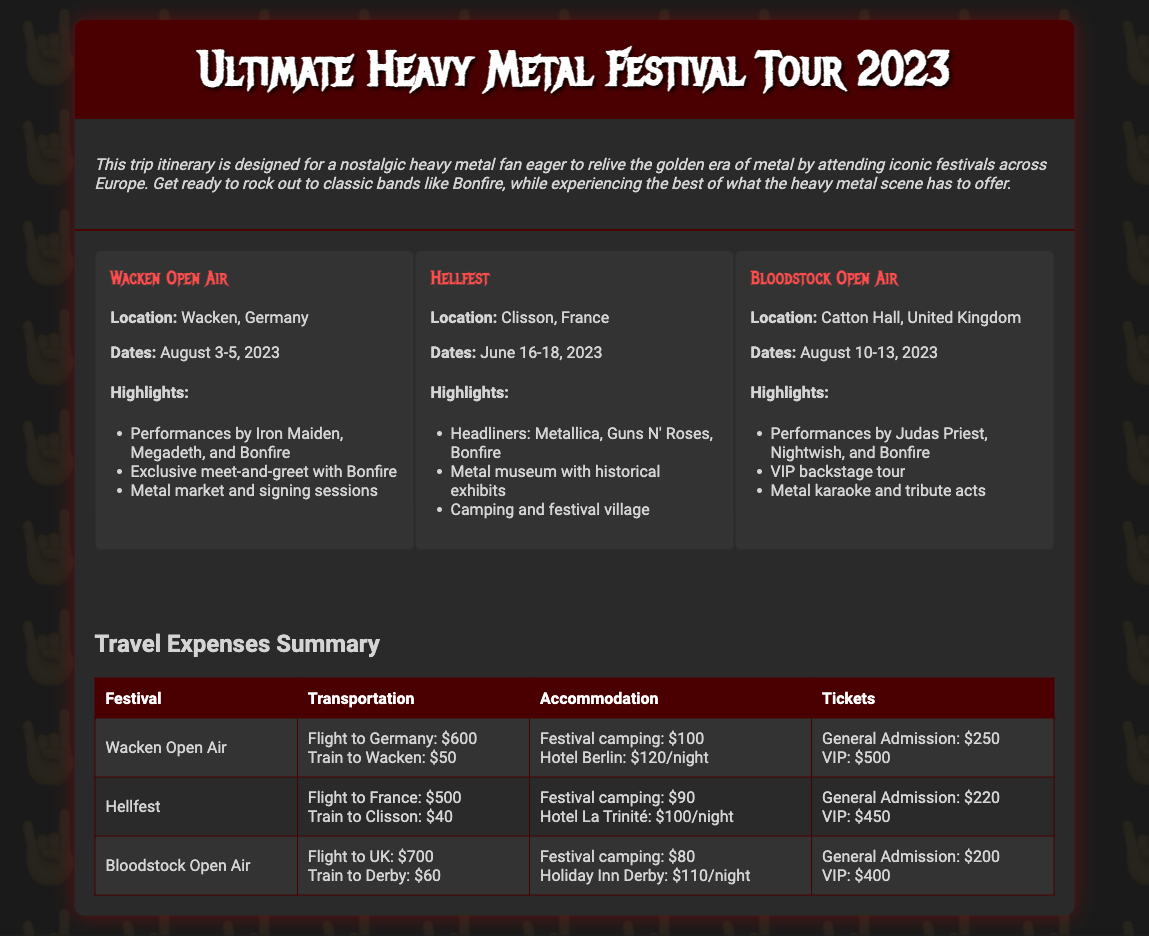What are the dates for Wacken Open Air? The document specifies the dates for Wacken Open Air as August 3-5, 2023.
Answer: August 3-5, 2023 What is the location of Hellfest? The document states that Hellfest is located in Clisson, France.
Answer: Clisson, France What is the cost for a VIP ticket at Bloodstock Open Air? The document indicates that the cost for a VIP ticket at Bloodstock Open Air is $400.
Answer: $400 How much does festival camping cost at Wacken Open Air? The document outlines that festival camping at Wacken Open Air costs $100.
Answer: $100 Which festival features a meet-and-greet with Bonfire? The document mentions that Wacken Open Air features a meet-and-greet with Bonfire.
Answer: Wacken Open Air What is the total transportation cost for attending Hellfest? The document details the transportation costs for Hellfest, which sum up to $540 (flight $500 + train $40).
Answer: $540 Which festival has the earliest date in 2023? The document lists Hellfest with the earliest date from June 16-18, 2023.
Answer: Hellfest What types of accommodations are listed for Bloodstock Open Air? The document provides information about festival camping and a Holiday Inn for Bloodstock Open Air.
Answer: Festival camping, Holiday Inn Derby 